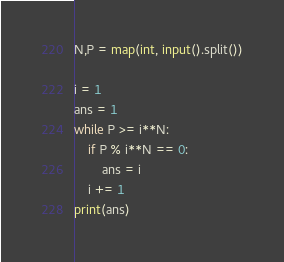<code> <loc_0><loc_0><loc_500><loc_500><_Python_>N,P = map(int, input().split())

i = 1
ans = 1
while P >= i**N:
	if P % i**N == 0:
		ans = i
	i += 1
print(ans)

</code> 